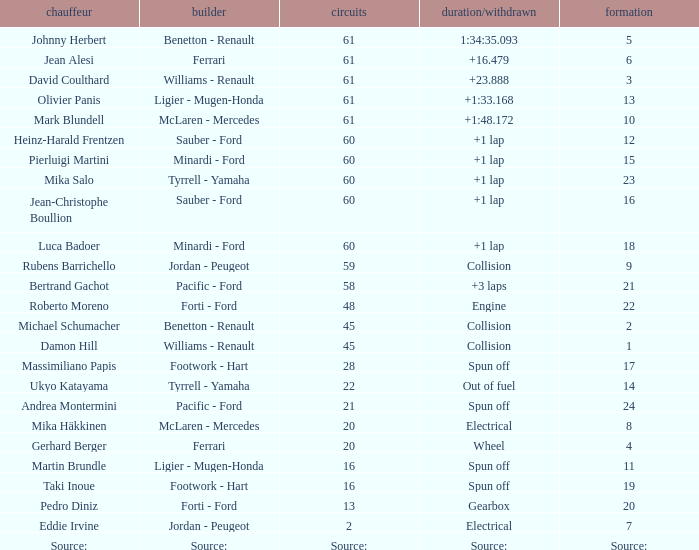How many laps does jean-christophe boullion have with a time/retired of +1 lap? 60.0. 